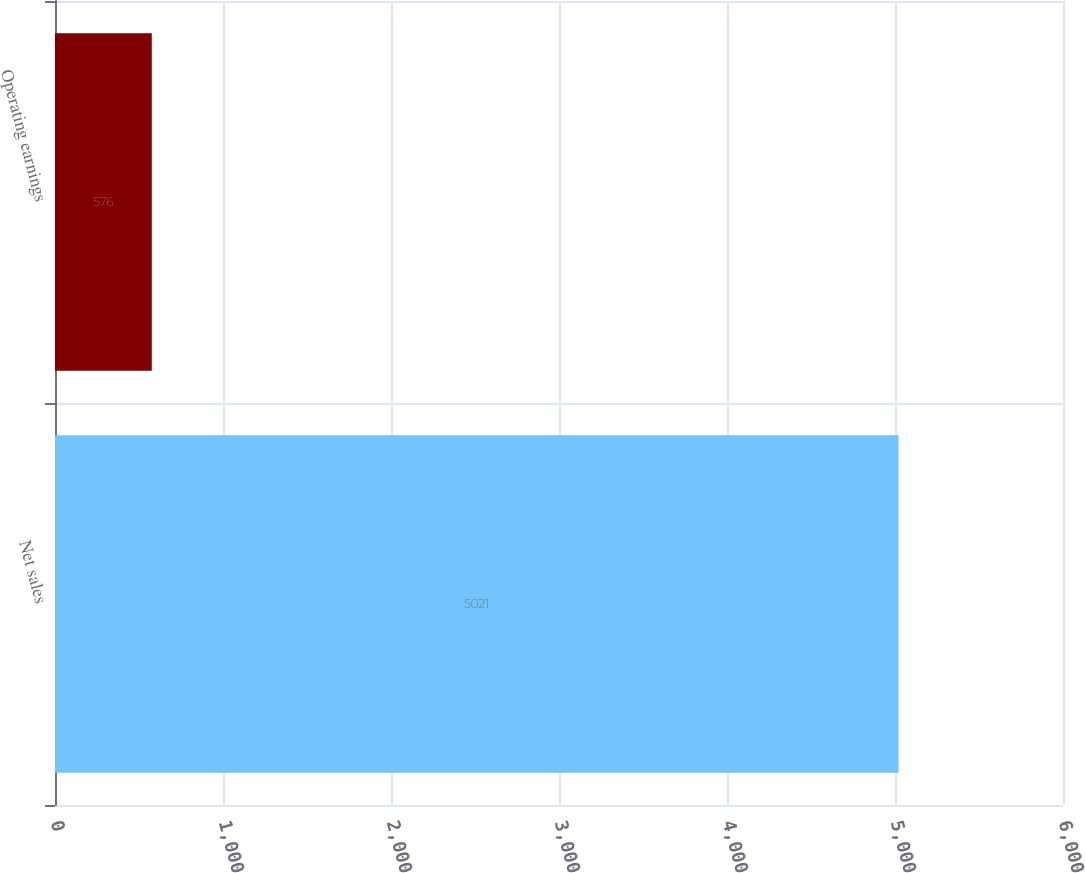Convert chart to OTSL. <chart><loc_0><loc_0><loc_500><loc_500><bar_chart><fcel>Net sales<fcel>Operating earnings<nl><fcel>5021<fcel>576<nl></chart> 